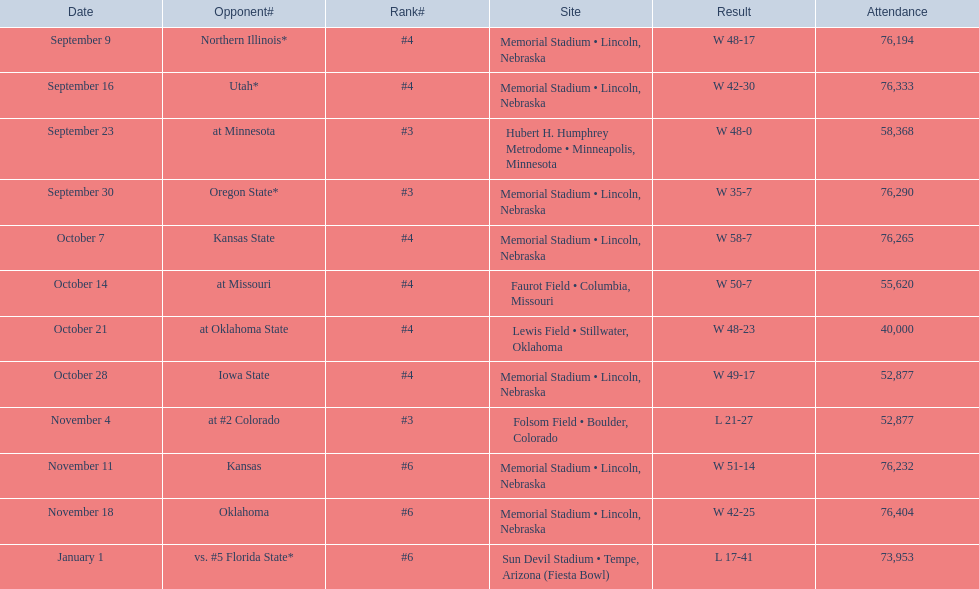When was the nebraska versus oregon state game held? September 30. How many people attended the game on september 30? 76,290. 